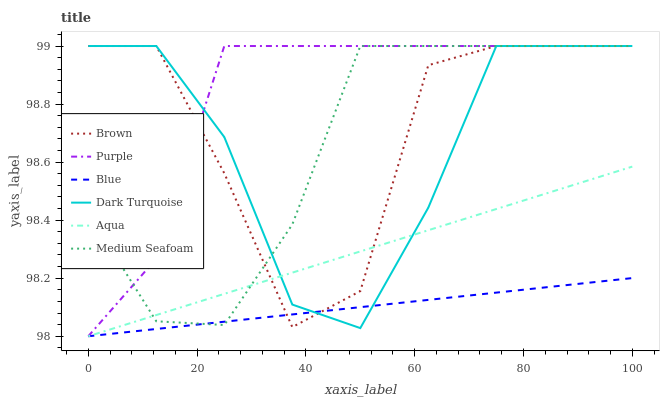Does Blue have the minimum area under the curve?
Answer yes or no. Yes. Does Purple have the maximum area under the curve?
Answer yes or no. Yes. Does Brown have the minimum area under the curve?
Answer yes or no. No. Does Brown have the maximum area under the curve?
Answer yes or no. No. Is Aqua the smoothest?
Answer yes or no. Yes. Is Brown the roughest?
Answer yes or no. Yes. Is Purple the smoothest?
Answer yes or no. No. Is Purple the roughest?
Answer yes or no. No. Does Brown have the lowest value?
Answer yes or no. No. Does Aqua have the highest value?
Answer yes or no. No. Is Blue less than Purple?
Answer yes or no. Yes. Is Purple greater than Aqua?
Answer yes or no. Yes. Does Blue intersect Purple?
Answer yes or no. No. 